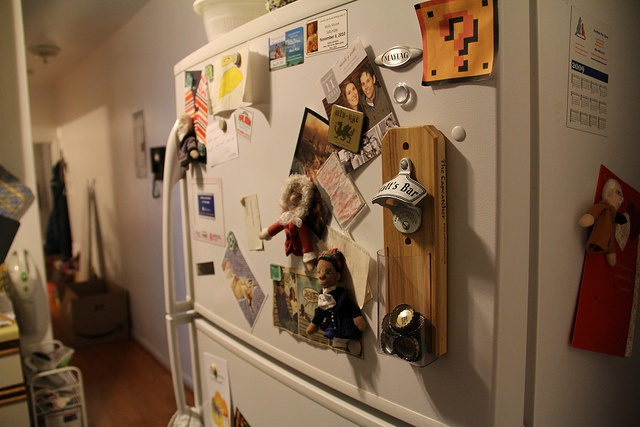Describe the objects in this image and their specific colors. I can see a refrigerator in gray, maroon, and tan tones in this image. 